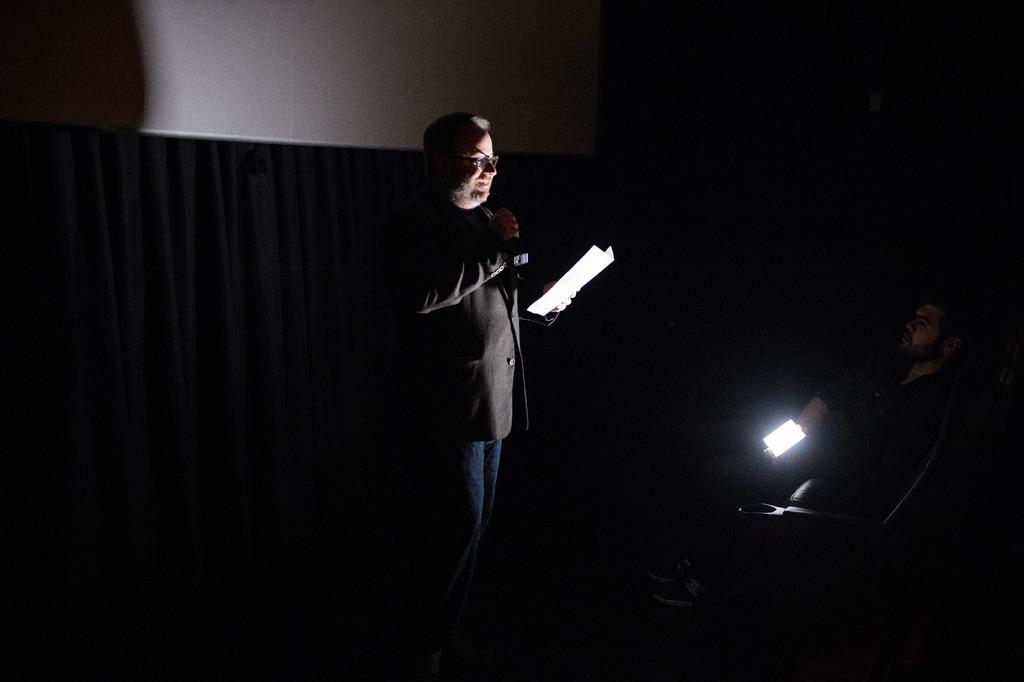How many people are in the image? There are two persons in the image. What is the person on the right side holding? The person on the right side is holding a light. What is the person in the middle holding? The person in the middle is holding a microphone (Mike) and a paper. What can be seen behind the person holding the paper? There is a curtain visible behind the person holding the paper. What type of waste can be seen on the floor in the image? There is no waste visible on the floor in the image. How many feet are visible in the image? The provided facts do not mention any feet or shoes, so it is impossible to determine how many feet are visible in the image. 